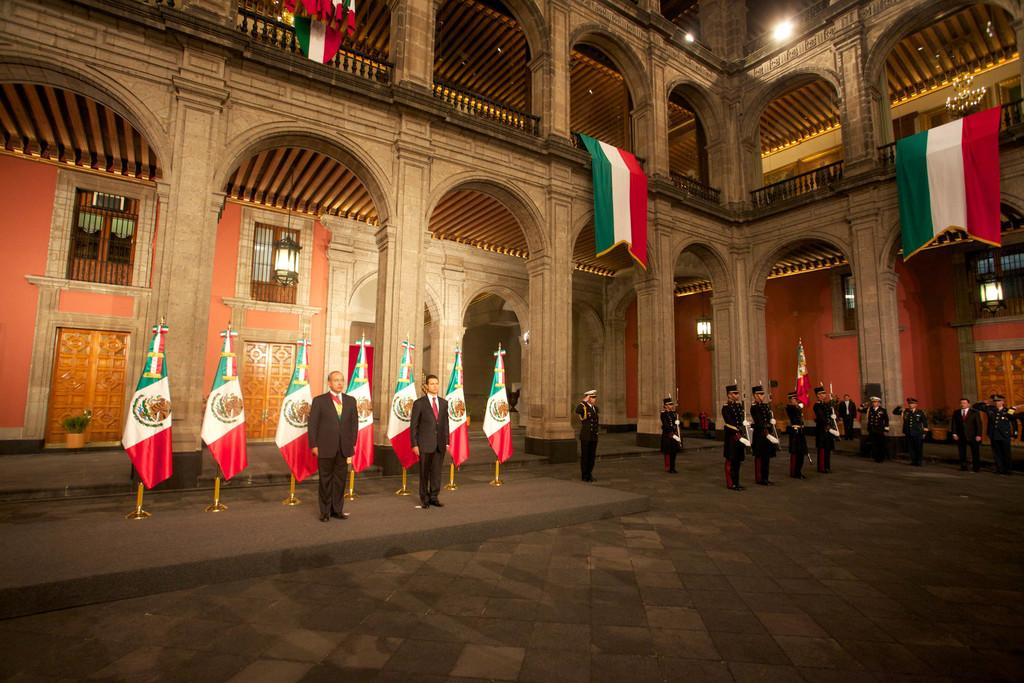Where was the image taken? The image was taken inside a building. What can be seen in the image? There are people standing in the image. What is visible in the background of the image? There are flags and pillars in the background of the image. Where are the flags located in the image? There are flags in the background and at the top of the image. Can you tell me how many cherries are hanging from the bead in the image? There are no cherries or beads present in the image. 